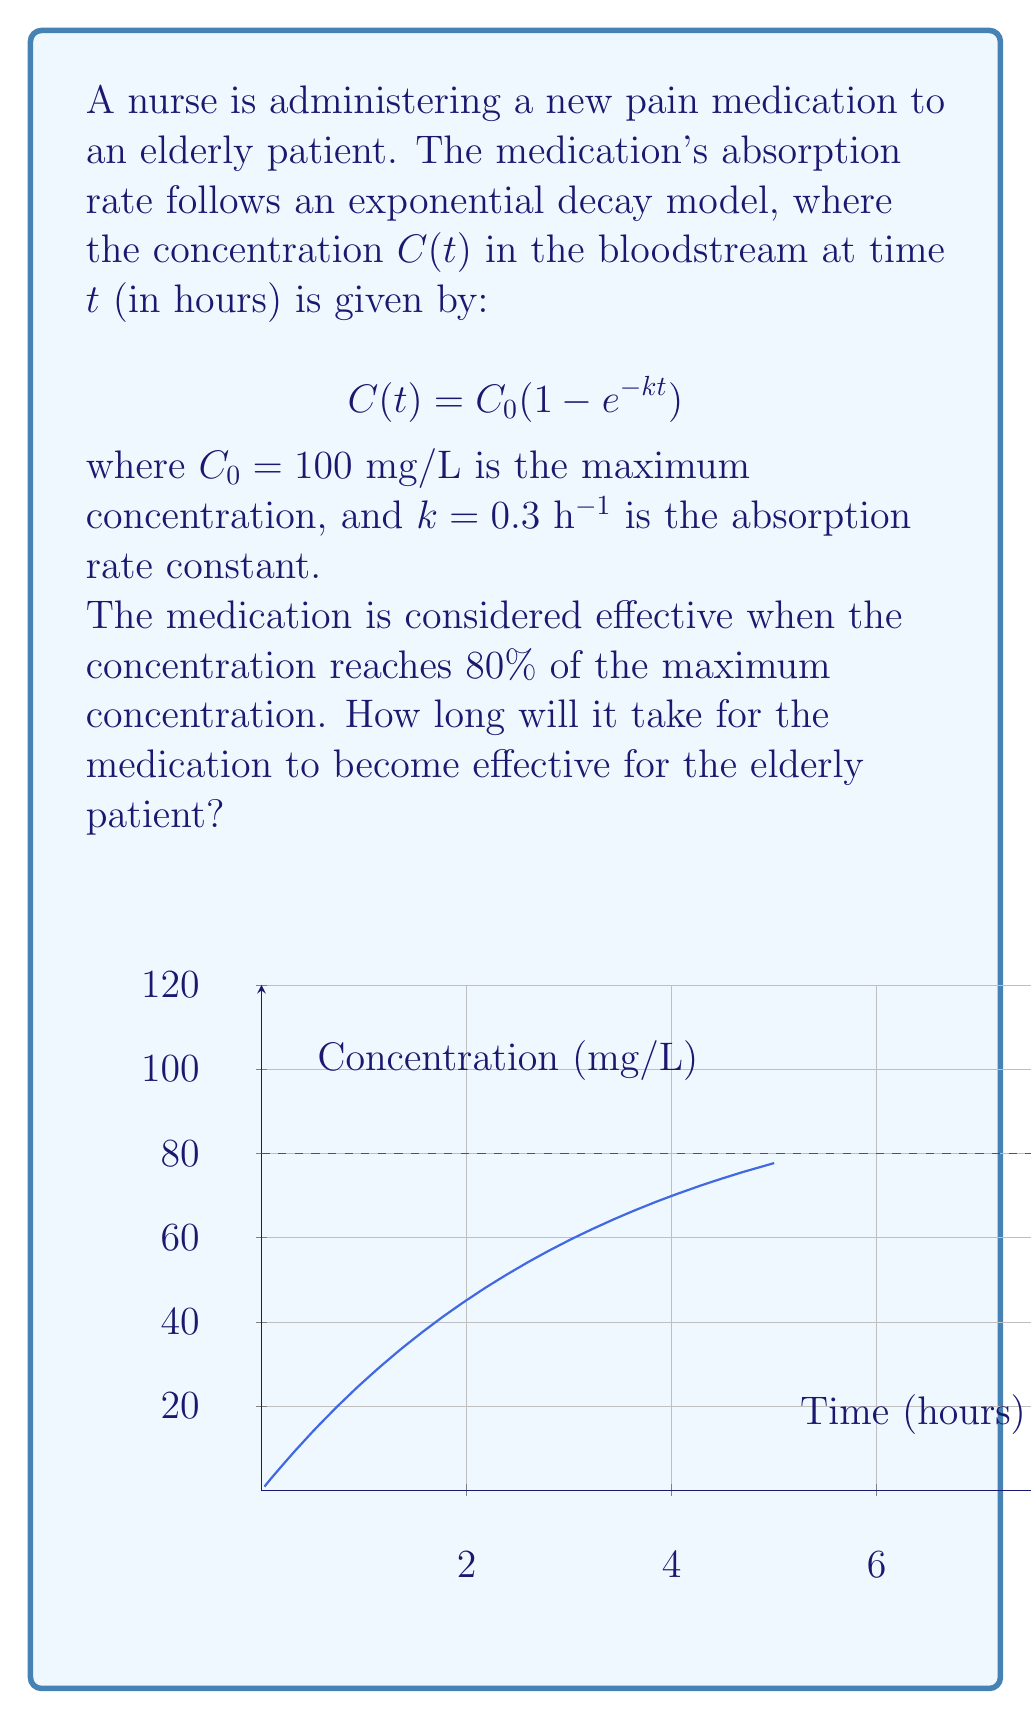Show me your answer to this math problem. To solve this problem, we need to follow these steps:

1) We know that the medication is effective when the concentration reaches 80% of the maximum concentration. Let's call this effective concentration $C_e$:

   $C_e = 0.8 \times C_0 = 0.8 \times 100 = 80$ mg/L

2) Now, we need to find the time $t$ when $C(t) = C_e$. We can set up the equation:

   $80 = 100(1 - e^{-0.3t})$

3) Let's solve this equation for $t$:
   
   $0.8 = 1 - e^{-0.3t}$
   $e^{-0.3t} = 0.2$

4) Taking the natural logarithm of both sides:

   $-0.3t = \ln(0.2)$

5) Solving for $t$:

   $t = -\frac{\ln(0.2)}{0.3}$

6) Calculate the result:

   $t \approx 5.37$ hours

Therefore, it will take approximately 5.37 hours for the medication to become effective for the elderly patient.
Answer: 5.37 hours 